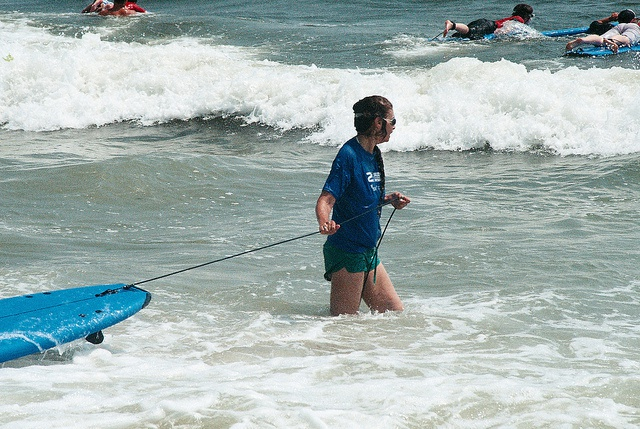Describe the objects in this image and their specific colors. I can see people in gray, black, navy, and maroon tones, surfboard in gray, teal, and lightblue tones, surfboard in gray, darkgray, and lightgray tones, people in gray, lightgray, darkgray, and black tones, and people in gray, black, purple, and brown tones in this image. 